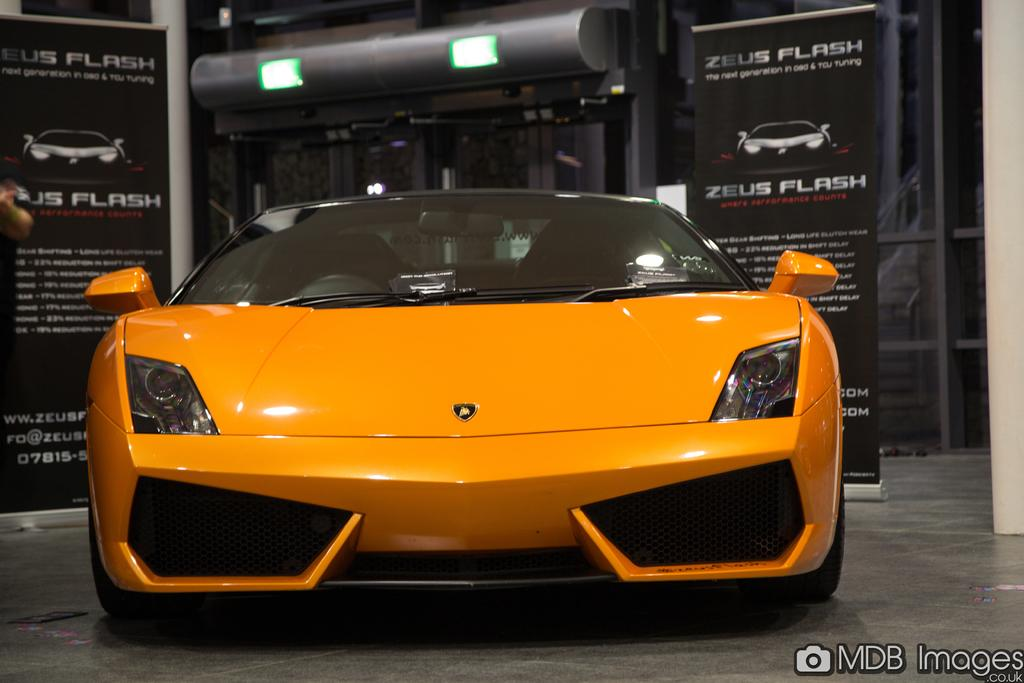What is the main subject of the image? The main subject of the image is a car. What else can be seen in the image besides the car? There are banners and lights in the image. What type of tooth is being used to hold the banner in the image? There is no tooth present in the image, and therefore no tooth is being used to hold the banner. 